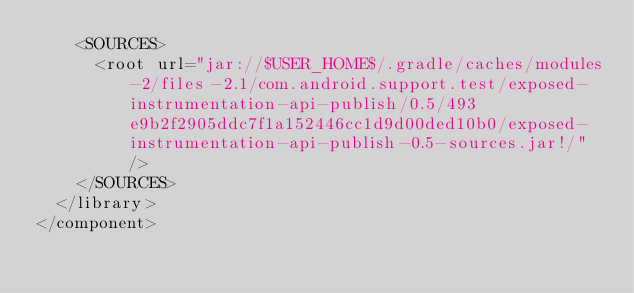<code> <loc_0><loc_0><loc_500><loc_500><_XML_>    <SOURCES>
      <root url="jar://$USER_HOME$/.gradle/caches/modules-2/files-2.1/com.android.support.test/exposed-instrumentation-api-publish/0.5/493e9b2f2905ddc7f1a152446cc1d9d00ded10b0/exposed-instrumentation-api-publish-0.5-sources.jar!/" />
    </SOURCES>
  </library>
</component></code> 